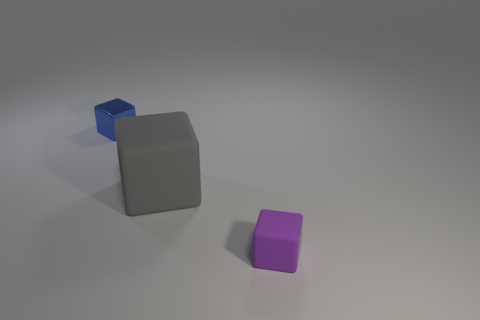Subtract all gray cubes. Subtract all purple cylinders. How many cubes are left? 2 Add 2 tiny purple things. How many objects exist? 5 Subtract 0 yellow balls. How many objects are left? 3 Subtract all small things. Subtract all big matte balls. How many objects are left? 1 Add 1 small matte objects. How many small matte objects are left? 2 Add 2 blue matte spheres. How many blue matte spheres exist? 2 